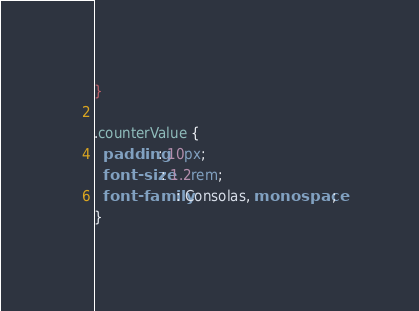<code> <loc_0><loc_0><loc_500><loc_500><_CSS_>}

.counterValue {
  padding: 10px;
  font-size: 1.2rem;
  font-family: Consolas, monospace;
}
</code> 